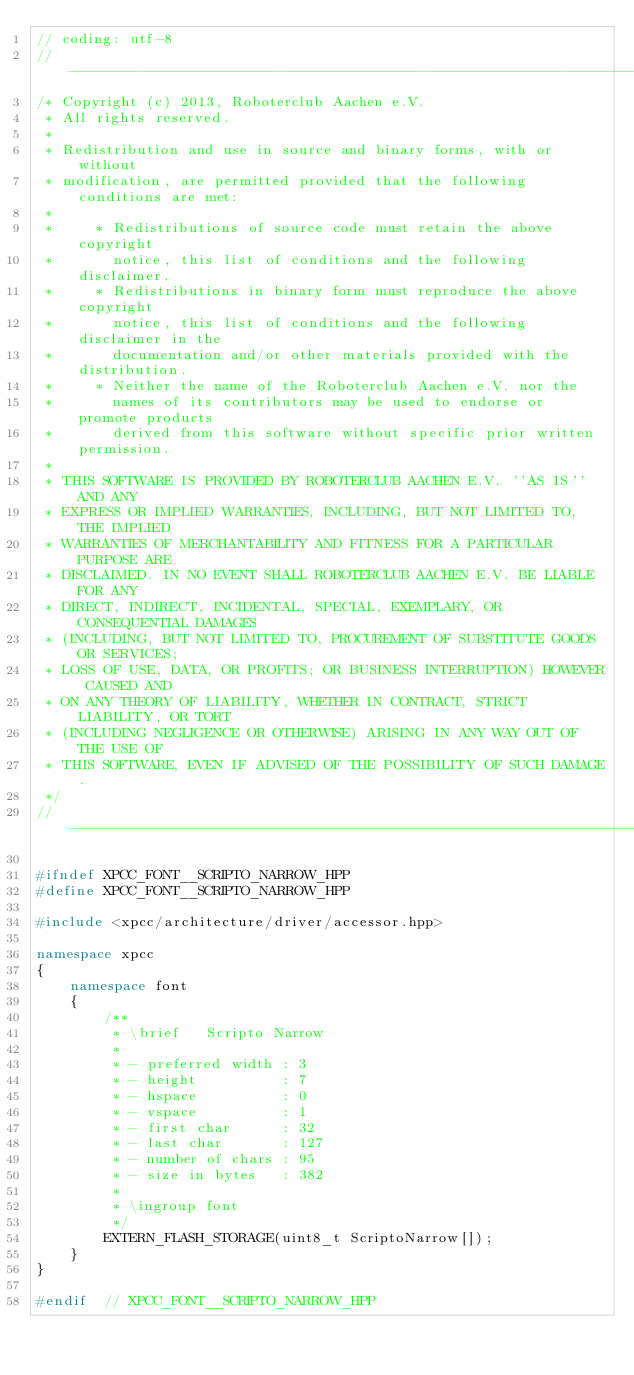<code> <loc_0><loc_0><loc_500><loc_500><_C++_>// coding: utf-8
// ----------------------------------------------------------------------------
/* Copyright (c) 2013, Roboterclub Aachen e.V.
 * All rights reserved.
 *
 * Redistribution and use in source and binary forms, with or without
 * modification, are permitted provided that the following conditions are met:
 * 
 *     * Redistributions of source code must retain the above copyright
 *       notice, this list of conditions and the following disclaimer.
 *     * Redistributions in binary form must reproduce the above copyright
 *       notice, this list of conditions and the following disclaimer in the
 *       documentation and/or other materials provided with the distribution.
 *     * Neither the name of the Roboterclub Aachen e.V. nor the
 *       names of its contributors may be used to endorse or promote products
 *       derived from this software without specific prior written permission.
 *
 * THIS SOFTWARE IS PROVIDED BY ROBOTERCLUB AACHEN E.V. ''AS IS'' AND ANY
 * EXPRESS OR IMPLIED WARRANTIES, INCLUDING, BUT NOT LIMITED TO, THE IMPLIED
 * WARRANTIES OF MERCHANTABILITY AND FITNESS FOR A PARTICULAR PURPOSE ARE
 * DISCLAIMED. IN NO EVENT SHALL ROBOTERCLUB AACHEN E.V. BE LIABLE FOR ANY
 * DIRECT, INDIRECT, INCIDENTAL, SPECIAL, EXEMPLARY, OR CONSEQUENTIAL DAMAGES
 * (INCLUDING, BUT NOT LIMITED TO, PROCUREMENT OF SUBSTITUTE GOODS OR SERVICES;
 * LOSS OF USE, DATA, OR PROFITS; OR BUSINESS INTERRUPTION) HOWEVER CAUSED AND
 * ON ANY THEORY OF LIABILITY, WHETHER IN CONTRACT, STRICT LIABILITY, OR TORT
 * (INCLUDING NEGLIGENCE OR OTHERWISE) ARISING IN ANY WAY OUT OF THE USE OF
 * THIS SOFTWARE, EVEN IF ADVISED OF THE POSSIBILITY OF SUCH DAMAGE.
 */
// ----------------------------------------------------------------------------

#ifndef XPCC_FONT__SCRIPTO_NARROW_HPP
#define	XPCC_FONT__SCRIPTO_NARROW_HPP

#include <xpcc/architecture/driver/accessor.hpp>

namespace xpcc
{
	namespace font
	{
		/**
		 * \brief	Scripto Narrow
		 * 
		 * - preferred width : 3
		 * - height          : 7
		 * - hspace          : 0
		 * - vspace          : 1
		 * - first char      : 32
		 * - last char       : 127
		 * - number of chars : 95
		 * - size in bytes   : 382
		 * 
		 * \ingroup	font
		 */
		EXTERN_FLASH_STORAGE(uint8_t ScriptoNarrow[]);
	}
}

#endif	// XPCC_FONT__SCRIPTO_NARROW_HPP

</code> 